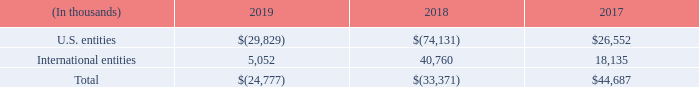Income (loss) before expense (benefit) for income taxes for the years ended December 31, 2019, 2018 and 2017 is as follows:
Income (loss) before expense (benefit) for income taxes for international entities reflects income (loss) based on statutory transfer pricing agreements. This amount does not correlate to consolidated international revenue, many of which occur from our U.S. entity.
What does Income (loss) before expense (benefit) for income taxes for international entities reflect? Income (loss) based on statutory transfer pricing agreements. What was the total income(loss) in 2017?
Answer scale should be: thousand. $44,687. What was the income for U.S. entities in 2019?
Answer scale should be: thousand. $(29,829). What was the percentage change for total income between 2018 and 2019?
Answer scale should be: percent. (-$24,777-(-$33,371))/-$33,371
Answer: -25.75. What was the change in income from International entities between 2018 and 2019?
Answer scale should be: thousand. 5,052-40,760
Answer: -35708. What was the change in income from U.S. entities between 2018 and 2019?
Answer scale should be: thousand. -$29,829-(-$74,131)
Answer: 44302. 